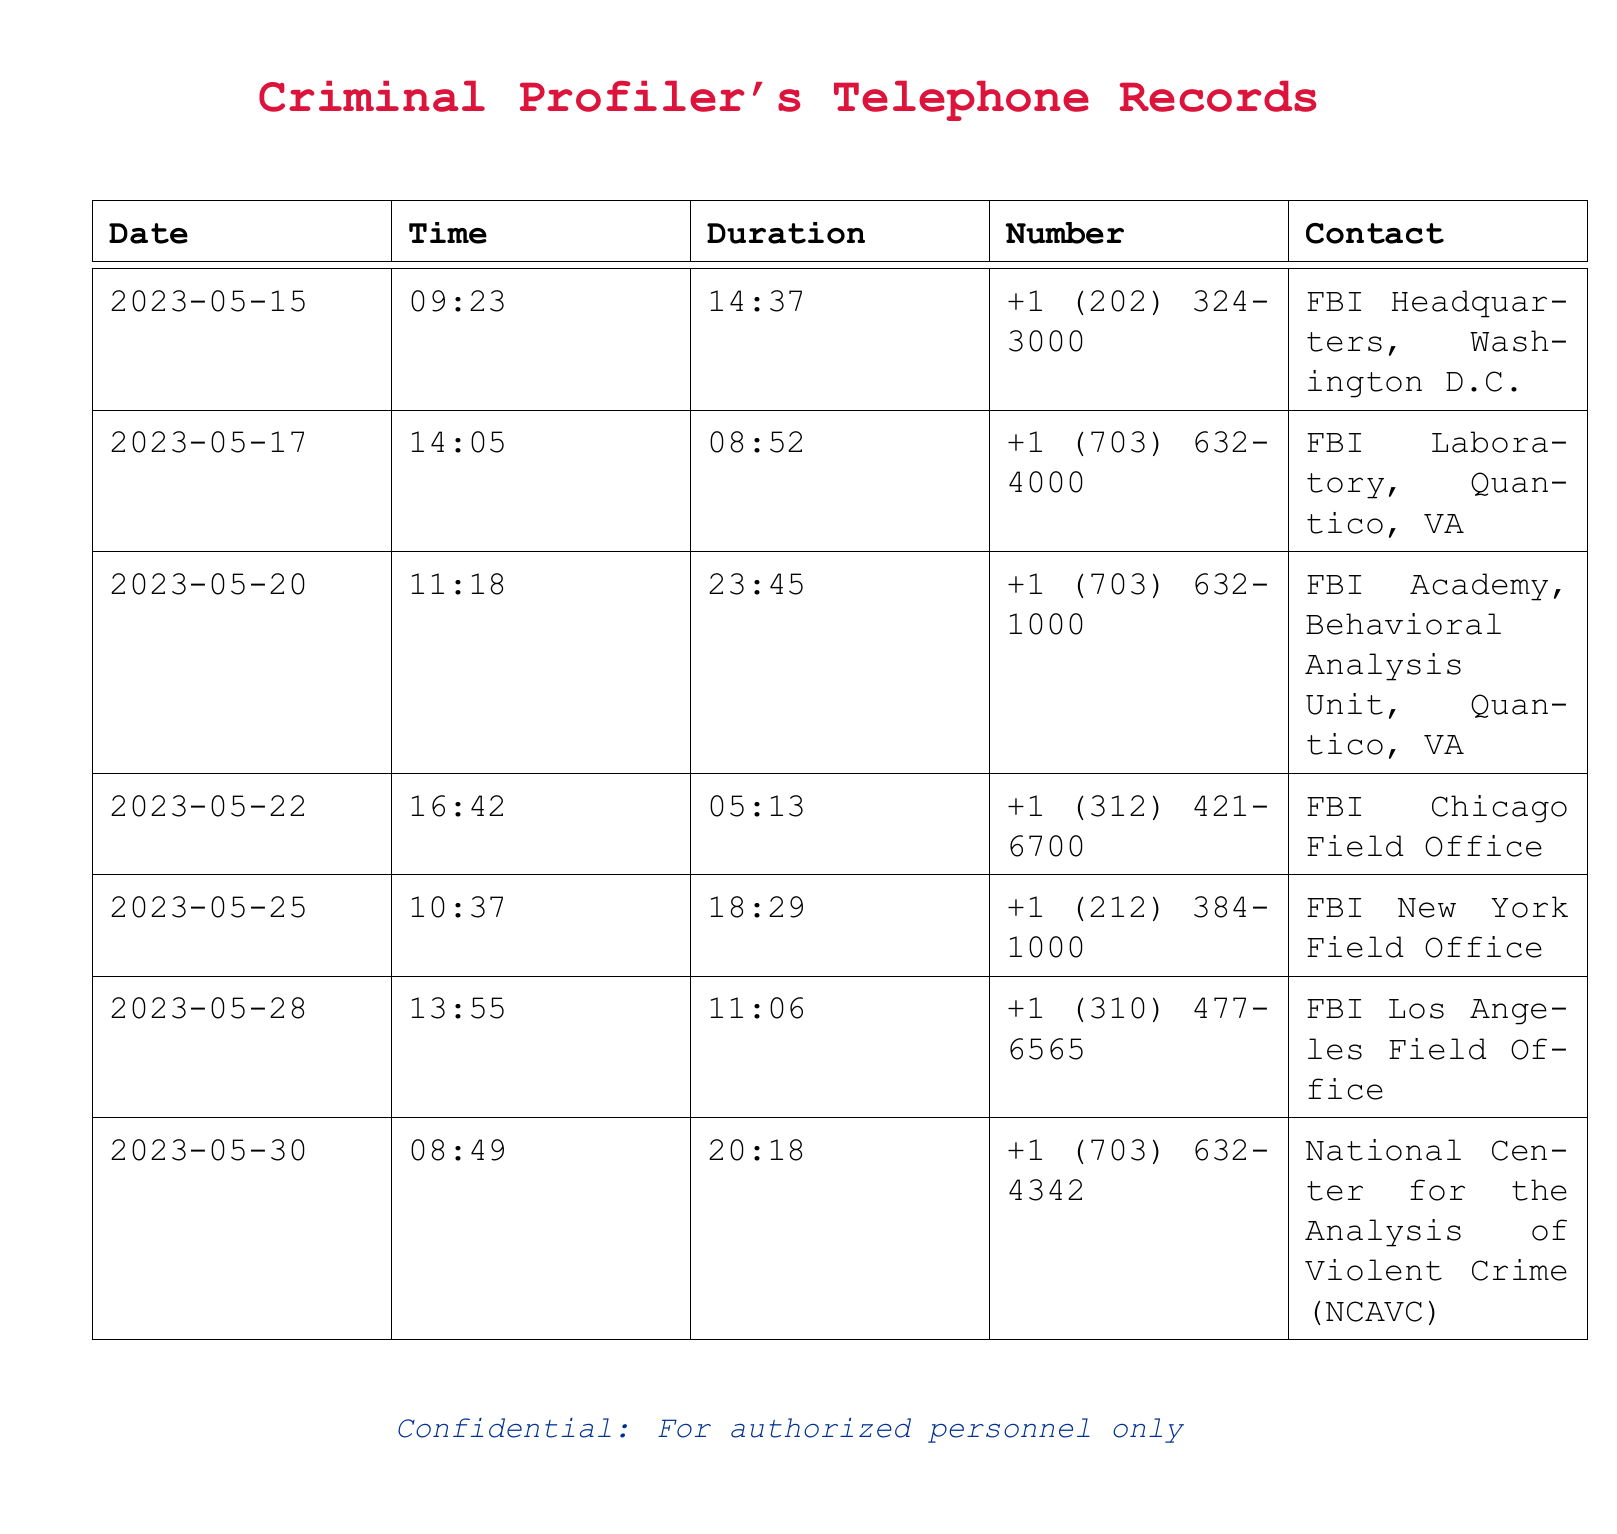what is the date of the first recorded call? The first call in the records is on May 15, 2023.
Answer: May 15, 2023 how long was the call to the FBI Academy? The duration of the call to the FBI Academy on May 20, 2023, was 23 minutes and 45 seconds.
Answer: 23:45 which FBI field office was contacted last? The last field office contacted was the FBI Los Angeles Field Office.
Answer: FBI Los Angeles Field Office what is the phone number for the FBI Chicago Field Office? The phone number for the FBI Chicago Field Office is +1 (312) 421-6700.
Answer: +1 (312) 421-6700 how many calls were made to the FBI field offices? There were three calls made to different FBI field offices listed in the records.
Answer: 3 which call had the shortest duration? The call to the FBI Chicago Field Office had the shortest duration of 5 minutes and 13 seconds.
Answer: 05:13 when was the call made to the National Center for the Analysis of Violent Crime? The call to the National Center for the Analysis of Violent Crime was made on May 30, 2023.
Answer: May 30, 2023 who is the primary contact in these records? The primary contact is the FBI, including various field offices and analysis units.
Answer: FBI 